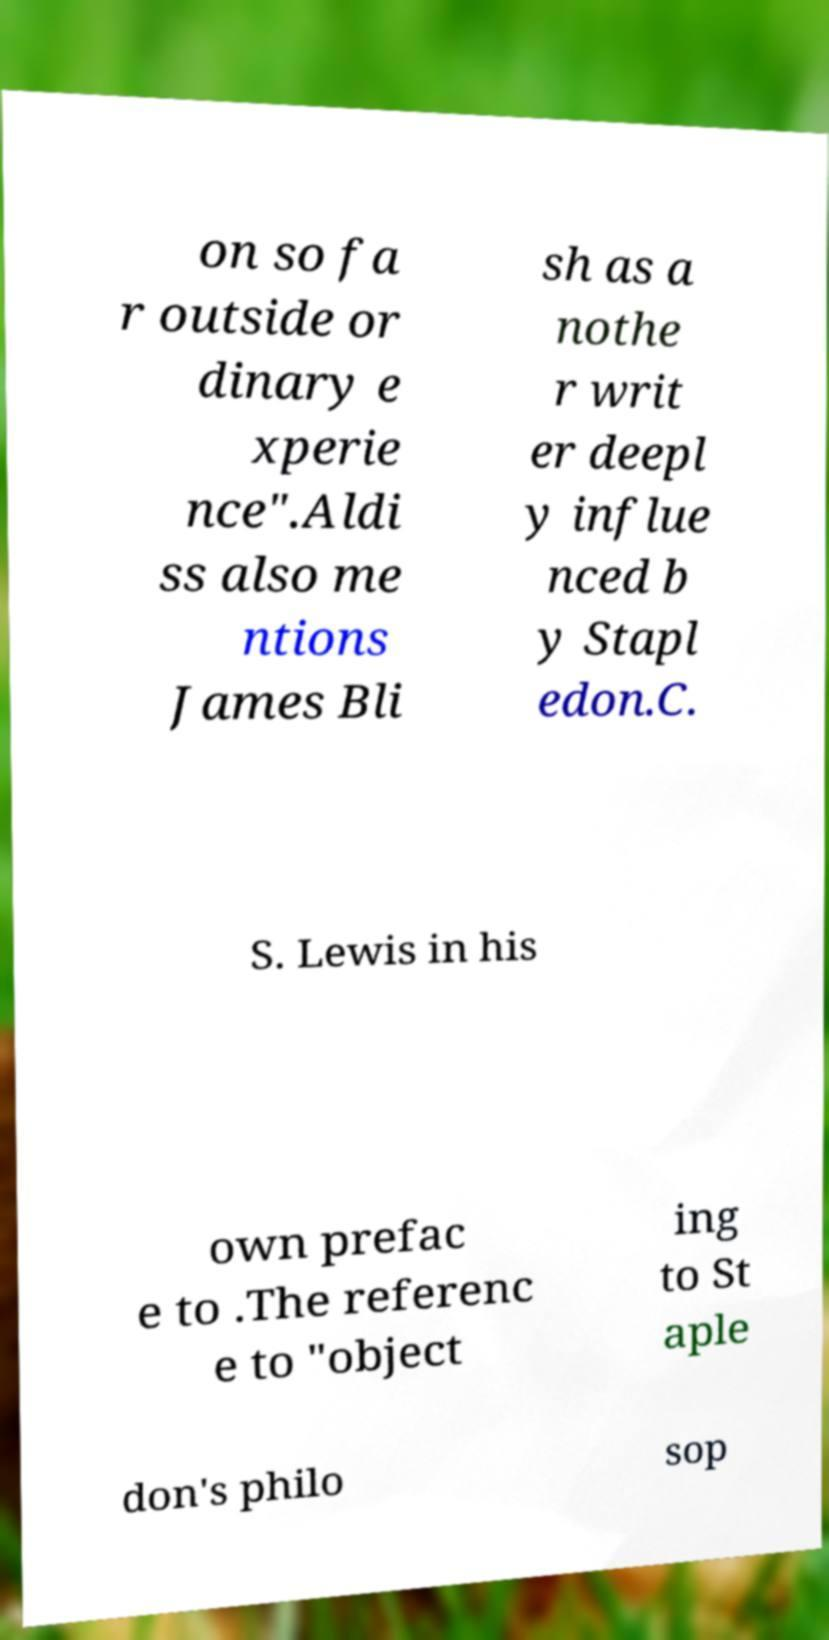Can you accurately transcribe the text from the provided image for me? on so fa r outside or dinary e xperie nce".Aldi ss also me ntions James Bli sh as a nothe r writ er deepl y influe nced b y Stapl edon.C. S. Lewis in his own prefac e to .The referenc e to "object ing to St aple don's philo sop 